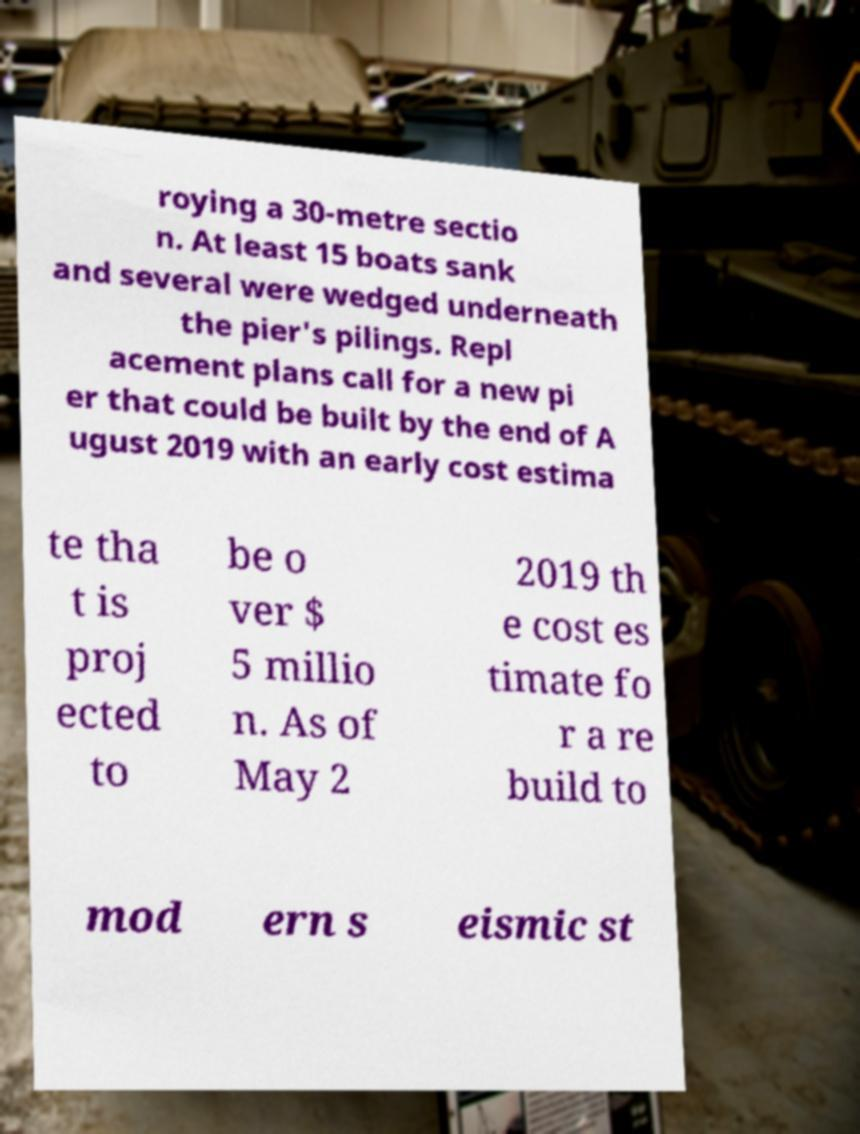Please read and relay the text visible in this image. What does it say? roying a 30-metre sectio n. At least 15 boats sank and several were wedged underneath the pier's pilings. Repl acement plans call for a new pi er that could be built by the end of A ugust 2019 with an early cost estima te tha t is proj ected to be o ver $ 5 millio n. As of May 2 2019 th e cost es timate fo r a re build to mod ern s eismic st 